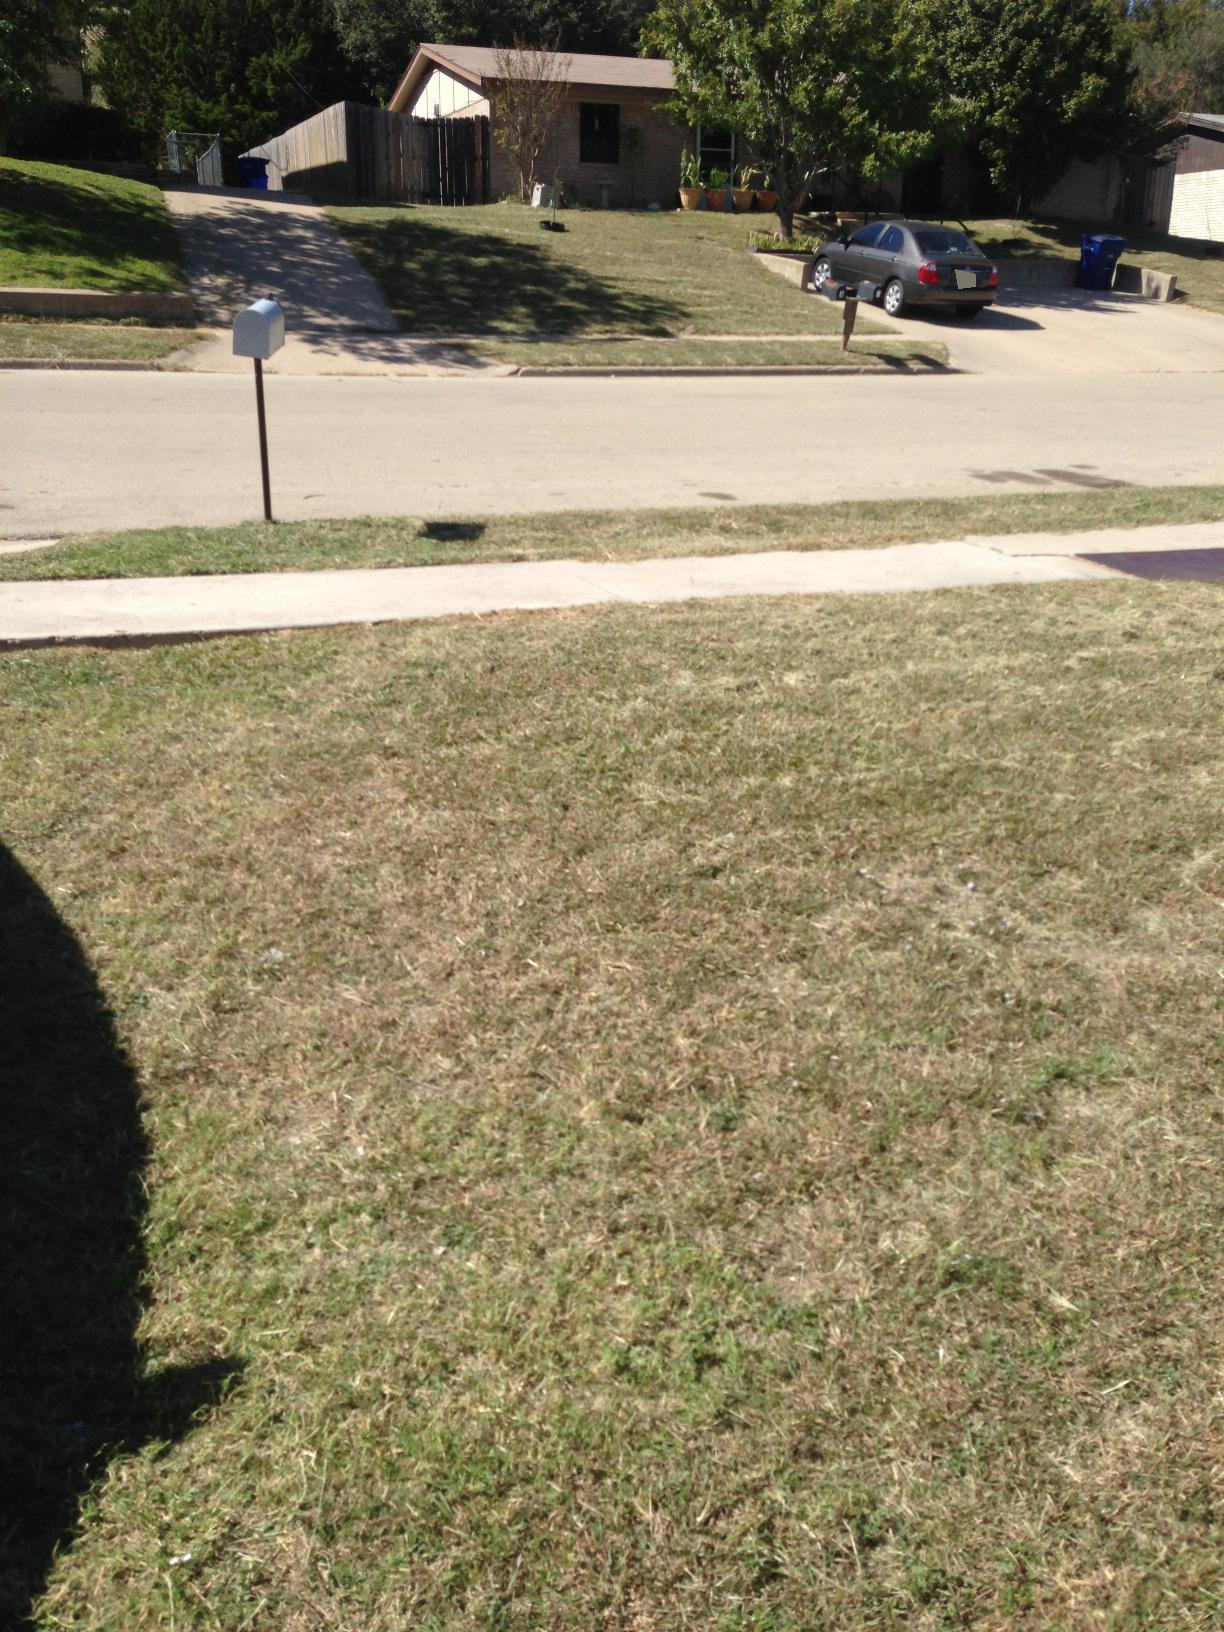If this street could talk, what stories would it tell? If this street could talk, it might share stories of changing seasons—how its trees bloom beautifully in spring and shed leaves in autumn. It would chronicle decades of families moving in and out, children growing up, playing in the yards, and making lifelong friendships. The streetlights would whisper about late-night walks and quiet reflections under their glow. It might even reminisce about the time when the neighborhood came together for a surprising snow day in this traditionally warm place, building snowmen and having snowball fights. Each crack and groove in the asphalt would have its own story to tell about the life and times of this simple yet storied street. 